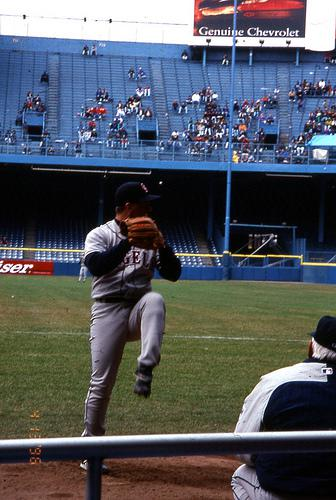Question: who is pictured?
Choices:
A. A football player.
B. A basketball player.
C. A tennis player.
D. A baseball player.
Answer with the letter. Answer: D Question: what is the player doing?
Choices:
A. Dancing.
B. Warming up for the game.
C. Pitching.
D. Hitting.
Answer with the letter. Answer: B Question: where was this photo taken?
Choices:
A. On a soccer field.
B. On a baseball field.
C. On a basketball court.
D. On a tennis court.
Answer with the letter. Answer: B Question: how many players can be seen?
Choices:
A. 2 players.
B. 3 players.
C. 1 player.
D. 4 players.
Answer with the letter. Answer: C Question: why was this photo taken?
Choices:
A. To show the man during warmups.
B. To identify a man by number.
C. To illustrate a move.
D. To save as a keepsake.
Answer with the letter. Answer: A 